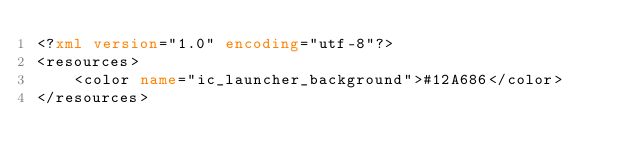Convert code to text. <code><loc_0><loc_0><loc_500><loc_500><_XML_><?xml version="1.0" encoding="utf-8"?>
<resources>
    <color name="ic_launcher_background">#12A686</color>
</resources></code> 